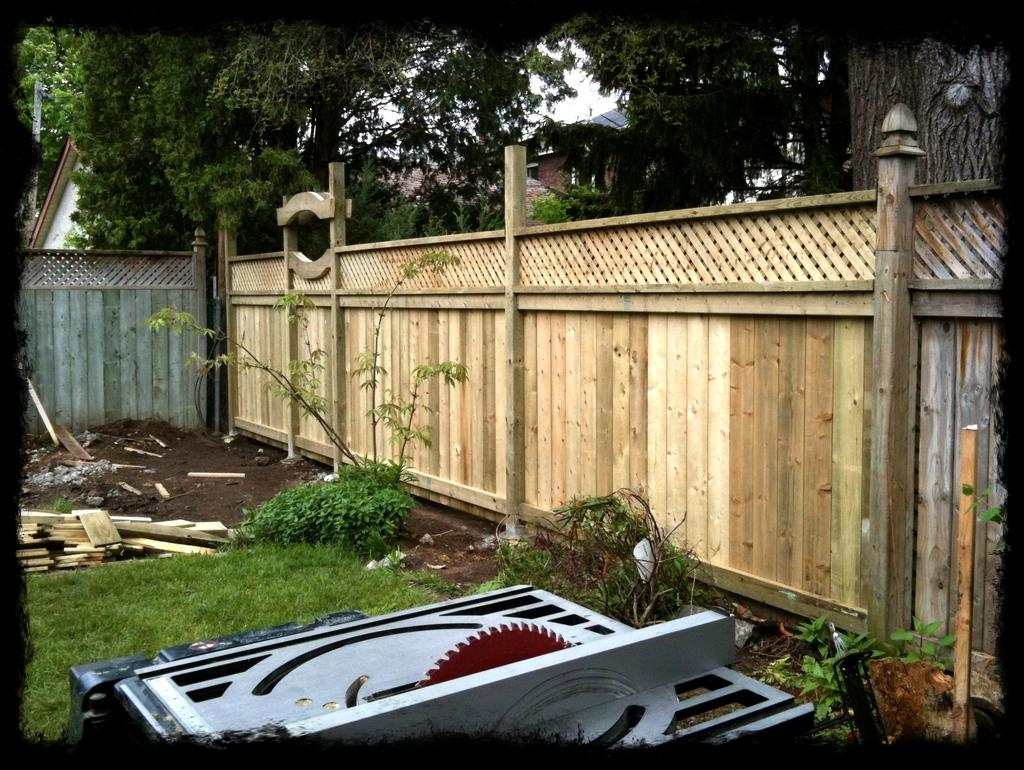What type of fencing is visible in the image? There is a wooden fencing in the image. What is on the grass in the image? Objects are placed on the grass in the image. What can be seen in the distance in the image? There are trees and houses visible in the background of the image. What type of pail is being used by the farmer in the image? There is no pail or farmer present in the image. 